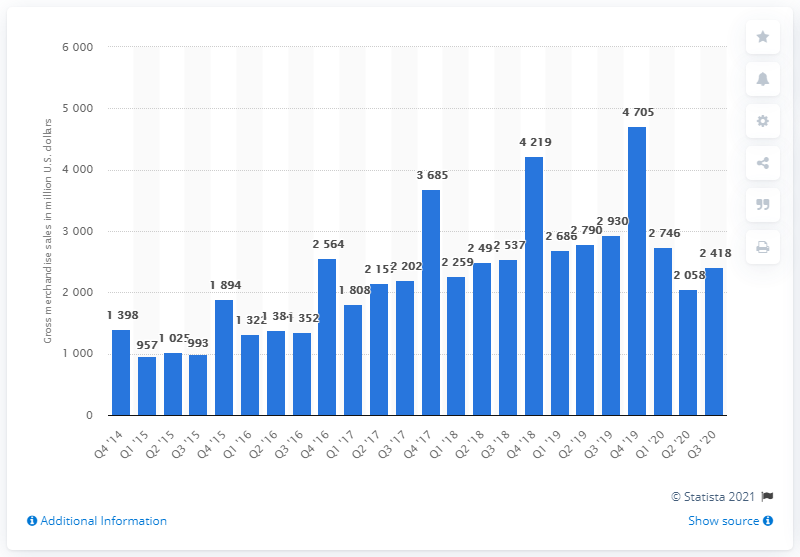Identify some key points in this picture. During the most recent reported period, Rakuten Rewards' GMS was 2,418. 